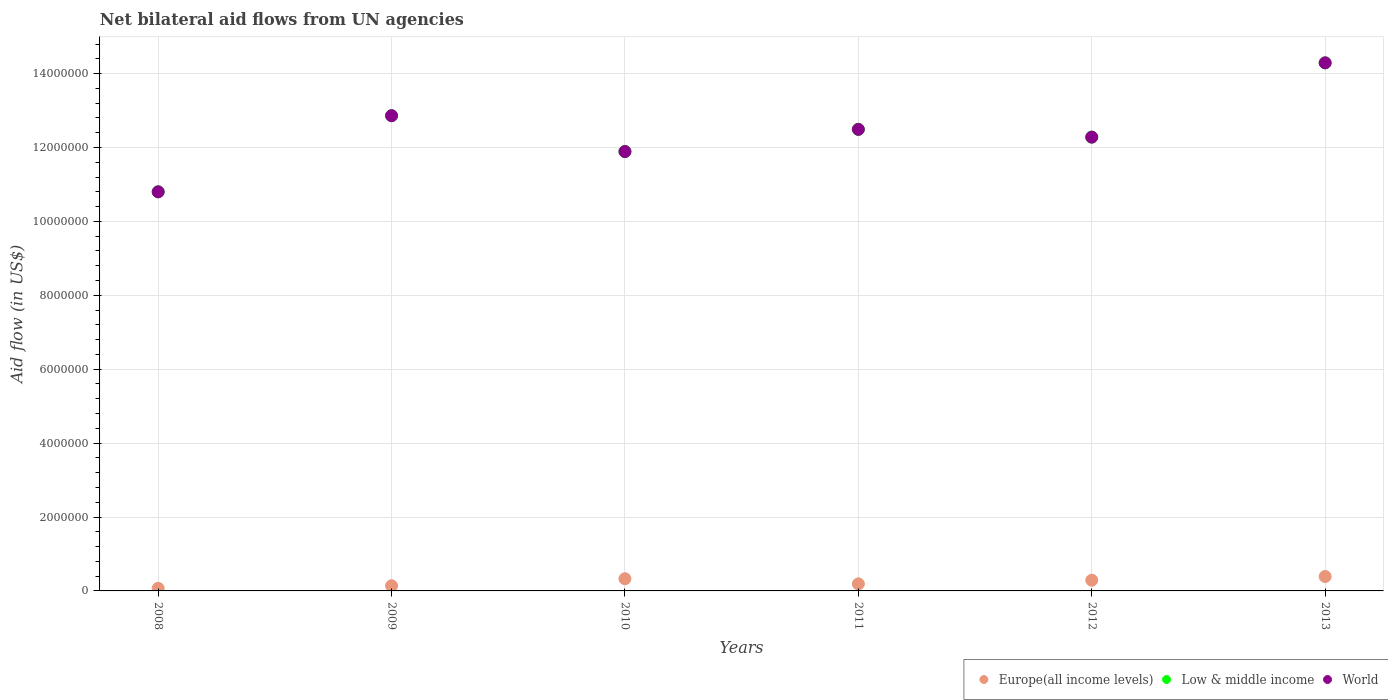What is the net bilateral aid flow in Europe(all income levels) in 2011?
Your answer should be compact. 1.90e+05. Across all years, what is the maximum net bilateral aid flow in Low & middle income?
Offer a very short reply. 1.43e+07. Across all years, what is the minimum net bilateral aid flow in Europe(all income levels)?
Provide a short and direct response. 7.00e+04. In which year was the net bilateral aid flow in Europe(all income levels) maximum?
Provide a succinct answer. 2013. In which year was the net bilateral aid flow in Europe(all income levels) minimum?
Provide a short and direct response. 2008. What is the total net bilateral aid flow in Europe(all income levels) in the graph?
Make the answer very short. 1.41e+06. What is the difference between the net bilateral aid flow in World in 2008 and that in 2013?
Offer a terse response. -3.49e+06. What is the difference between the net bilateral aid flow in Low & middle income in 2012 and the net bilateral aid flow in Europe(all income levels) in 2010?
Offer a very short reply. 1.20e+07. What is the average net bilateral aid flow in Low & middle income per year?
Your response must be concise. 1.24e+07. In the year 2010, what is the difference between the net bilateral aid flow in Low & middle income and net bilateral aid flow in World?
Your answer should be compact. 0. What is the ratio of the net bilateral aid flow in World in 2010 to that in 2011?
Ensure brevity in your answer.  0.95. Is the net bilateral aid flow in Low & middle income in 2011 less than that in 2012?
Offer a very short reply. No. Is the difference between the net bilateral aid flow in Low & middle income in 2010 and 2013 greater than the difference between the net bilateral aid flow in World in 2010 and 2013?
Keep it short and to the point. No. What is the difference between the highest and the second highest net bilateral aid flow in Europe(all income levels)?
Ensure brevity in your answer.  6.00e+04. What is the difference between the highest and the lowest net bilateral aid flow in World?
Offer a terse response. 3.49e+06. In how many years, is the net bilateral aid flow in Europe(all income levels) greater than the average net bilateral aid flow in Europe(all income levels) taken over all years?
Provide a succinct answer. 3. Is the sum of the net bilateral aid flow in World in 2008 and 2009 greater than the maximum net bilateral aid flow in Europe(all income levels) across all years?
Your answer should be compact. Yes. Is it the case that in every year, the sum of the net bilateral aid flow in Low & middle income and net bilateral aid flow in Europe(all income levels)  is greater than the net bilateral aid flow in World?
Provide a short and direct response. Yes. Does the net bilateral aid flow in World monotonically increase over the years?
Keep it short and to the point. No. How many dotlines are there?
Provide a short and direct response. 3. How many years are there in the graph?
Give a very brief answer. 6. What is the difference between two consecutive major ticks on the Y-axis?
Keep it short and to the point. 2.00e+06. Does the graph contain grids?
Offer a very short reply. Yes. How are the legend labels stacked?
Keep it short and to the point. Horizontal. What is the title of the graph?
Offer a very short reply. Net bilateral aid flows from UN agencies. Does "Euro area" appear as one of the legend labels in the graph?
Your answer should be compact. No. What is the label or title of the Y-axis?
Provide a succinct answer. Aid flow (in US$). What is the Aid flow (in US$) of Europe(all income levels) in 2008?
Give a very brief answer. 7.00e+04. What is the Aid flow (in US$) in Low & middle income in 2008?
Keep it short and to the point. 1.08e+07. What is the Aid flow (in US$) of World in 2008?
Your response must be concise. 1.08e+07. What is the Aid flow (in US$) in Europe(all income levels) in 2009?
Ensure brevity in your answer.  1.40e+05. What is the Aid flow (in US$) of Low & middle income in 2009?
Give a very brief answer. 1.29e+07. What is the Aid flow (in US$) of World in 2009?
Your answer should be very brief. 1.29e+07. What is the Aid flow (in US$) of Low & middle income in 2010?
Keep it short and to the point. 1.19e+07. What is the Aid flow (in US$) of World in 2010?
Give a very brief answer. 1.19e+07. What is the Aid flow (in US$) in Europe(all income levels) in 2011?
Offer a very short reply. 1.90e+05. What is the Aid flow (in US$) of Low & middle income in 2011?
Your answer should be compact. 1.25e+07. What is the Aid flow (in US$) of World in 2011?
Ensure brevity in your answer.  1.25e+07. What is the Aid flow (in US$) in Europe(all income levels) in 2012?
Your answer should be very brief. 2.90e+05. What is the Aid flow (in US$) of Low & middle income in 2012?
Offer a very short reply. 1.23e+07. What is the Aid flow (in US$) in World in 2012?
Offer a terse response. 1.23e+07. What is the Aid flow (in US$) in Europe(all income levels) in 2013?
Make the answer very short. 3.90e+05. What is the Aid flow (in US$) in Low & middle income in 2013?
Your response must be concise. 1.43e+07. What is the Aid flow (in US$) of World in 2013?
Offer a very short reply. 1.43e+07. Across all years, what is the maximum Aid flow (in US$) in Low & middle income?
Give a very brief answer. 1.43e+07. Across all years, what is the maximum Aid flow (in US$) in World?
Offer a terse response. 1.43e+07. Across all years, what is the minimum Aid flow (in US$) of Europe(all income levels)?
Your answer should be very brief. 7.00e+04. Across all years, what is the minimum Aid flow (in US$) in Low & middle income?
Your answer should be very brief. 1.08e+07. Across all years, what is the minimum Aid flow (in US$) in World?
Provide a succinct answer. 1.08e+07. What is the total Aid flow (in US$) in Europe(all income levels) in the graph?
Keep it short and to the point. 1.41e+06. What is the total Aid flow (in US$) of Low & middle income in the graph?
Give a very brief answer. 7.46e+07. What is the total Aid flow (in US$) of World in the graph?
Your response must be concise. 7.46e+07. What is the difference between the Aid flow (in US$) of Europe(all income levels) in 2008 and that in 2009?
Provide a short and direct response. -7.00e+04. What is the difference between the Aid flow (in US$) of Low & middle income in 2008 and that in 2009?
Offer a very short reply. -2.06e+06. What is the difference between the Aid flow (in US$) of World in 2008 and that in 2009?
Make the answer very short. -2.06e+06. What is the difference between the Aid flow (in US$) in Europe(all income levels) in 2008 and that in 2010?
Keep it short and to the point. -2.60e+05. What is the difference between the Aid flow (in US$) in Low & middle income in 2008 and that in 2010?
Your answer should be compact. -1.09e+06. What is the difference between the Aid flow (in US$) of World in 2008 and that in 2010?
Your answer should be compact. -1.09e+06. What is the difference between the Aid flow (in US$) in Low & middle income in 2008 and that in 2011?
Your answer should be compact. -1.69e+06. What is the difference between the Aid flow (in US$) of World in 2008 and that in 2011?
Your answer should be very brief. -1.69e+06. What is the difference between the Aid flow (in US$) of Europe(all income levels) in 2008 and that in 2012?
Your response must be concise. -2.20e+05. What is the difference between the Aid flow (in US$) in Low & middle income in 2008 and that in 2012?
Keep it short and to the point. -1.48e+06. What is the difference between the Aid flow (in US$) in World in 2008 and that in 2012?
Ensure brevity in your answer.  -1.48e+06. What is the difference between the Aid flow (in US$) of Europe(all income levels) in 2008 and that in 2013?
Keep it short and to the point. -3.20e+05. What is the difference between the Aid flow (in US$) of Low & middle income in 2008 and that in 2013?
Your answer should be very brief. -3.49e+06. What is the difference between the Aid flow (in US$) of World in 2008 and that in 2013?
Keep it short and to the point. -3.49e+06. What is the difference between the Aid flow (in US$) in Low & middle income in 2009 and that in 2010?
Your answer should be very brief. 9.70e+05. What is the difference between the Aid flow (in US$) of World in 2009 and that in 2010?
Offer a terse response. 9.70e+05. What is the difference between the Aid flow (in US$) of Europe(all income levels) in 2009 and that in 2011?
Provide a succinct answer. -5.00e+04. What is the difference between the Aid flow (in US$) of Low & middle income in 2009 and that in 2011?
Offer a terse response. 3.70e+05. What is the difference between the Aid flow (in US$) of Low & middle income in 2009 and that in 2012?
Keep it short and to the point. 5.80e+05. What is the difference between the Aid flow (in US$) in World in 2009 and that in 2012?
Your answer should be very brief. 5.80e+05. What is the difference between the Aid flow (in US$) in Europe(all income levels) in 2009 and that in 2013?
Your response must be concise. -2.50e+05. What is the difference between the Aid flow (in US$) of Low & middle income in 2009 and that in 2013?
Make the answer very short. -1.43e+06. What is the difference between the Aid flow (in US$) in World in 2009 and that in 2013?
Make the answer very short. -1.43e+06. What is the difference between the Aid flow (in US$) in Low & middle income in 2010 and that in 2011?
Give a very brief answer. -6.00e+05. What is the difference between the Aid flow (in US$) of World in 2010 and that in 2011?
Give a very brief answer. -6.00e+05. What is the difference between the Aid flow (in US$) in Europe(all income levels) in 2010 and that in 2012?
Give a very brief answer. 4.00e+04. What is the difference between the Aid flow (in US$) in Low & middle income in 2010 and that in 2012?
Offer a terse response. -3.90e+05. What is the difference between the Aid flow (in US$) of World in 2010 and that in 2012?
Give a very brief answer. -3.90e+05. What is the difference between the Aid flow (in US$) in Low & middle income in 2010 and that in 2013?
Your response must be concise. -2.40e+06. What is the difference between the Aid flow (in US$) of World in 2010 and that in 2013?
Offer a terse response. -2.40e+06. What is the difference between the Aid flow (in US$) in Low & middle income in 2011 and that in 2013?
Your response must be concise. -1.80e+06. What is the difference between the Aid flow (in US$) of World in 2011 and that in 2013?
Your answer should be compact. -1.80e+06. What is the difference between the Aid flow (in US$) in Low & middle income in 2012 and that in 2013?
Give a very brief answer. -2.01e+06. What is the difference between the Aid flow (in US$) of World in 2012 and that in 2013?
Offer a very short reply. -2.01e+06. What is the difference between the Aid flow (in US$) of Europe(all income levels) in 2008 and the Aid flow (in US$) of Low & middle income in 2009?
Provide a succinct answer. -1.28e+07. What is the difference between the Aid flow (in US$) of Europe(all income levels) in 2008 and the Aid flow (in US$) of World in 2009?
Provide a succinct answer. -1.28e+07. What is the difference between the Aid flow (in US$) of Low & middle income in 2008 and the Aid flow (in US$) of World in 2009?
Give a very brief answer. -2.06e+06. What is the difference between the Aid flow (in US$) of Europe(all income levels) in 2008 and the Aid flow (in US$) of Low & middle income in 2010?
Ensure brevity in your answer.  -1.18e+07. What is the difference between the Aid flow (in US$) in Europe(all income levels) in 2008 and the Aid flow (in US$) in World in 2010?
Provide a short and direct response. -1.18e+07. What is the difference between the Aid flow (in US$) in Low & middle income in 2008 and the Aid flow (in US$) in World in 2010?
Provide a short and direct response. -1.09e+06. What is the difference between the Aid flow (in US$) in Europe(all income levels) in 2008 and the Aid flow (in US$) in Low & middle income in 2011?
Your response must be concise. -1.24e+07. What is the difference between the Aid flow (in US$) in Europe(all income levels) in 2008 and the Aid flow (in US$) in World in 2011?
Offer a very short reply. -1.24e+07. What is the difference between the Aid flow (in US$) of Low & middle income in 2008 and the Aid flow (in US$) of World in 2011?
Provide a short and direct response. -1.69e+06. What is the difference between the Aid flow (in US$) of Europe(all income levels) in 2008 and the Aid flow (in US$) of Low & middle income in 2012?
Give a very brief answer. -1.22e+07. What is the difference between the Aid flow (in US$) in Europe(all income levels) in 2008 and the Aid flow (in US$) in World in 2012?
Your answer should be very brief. -1.22e+07. What is the difference between the Aid flow (in US$) in Low & middle income in 2008 and the Aid flow (in US$) in World in 2012?
Keep it short and to the point. -1.48e+06. What is the difference between the Aid flow (in US$) of Europe(all income levels) in 2008 and the Aid flow (in US$) of Low & middle income in 2013?
Make the answer very short. -1.42e+07. What is the difference between the Aid flow (in US$) in Europe(all income levels) in 2008 and the Aid flow (in US$) in World in 2013?
Offer a very short reply. -1.42e+07. What is the difference between the Aid flow (in US$) of Low & middle income in 2008 and the Aid flow (in US$) of World in 2013?
Keep it short and to the point. -3.49e+06. What is the difference between the Aid flow (in US$) in Europe(all income levels) in 2009 and the Aid flow (in US$) in Low & middle income in 2010?
Ensure brevity in your answer.  -1.18e+07. What is the difference between the Aid flow (in US$) in Europe(all income levels) in 2009 and the Aid flow (in US$) in World in 2010?
Provide a succinct answer. -1.18e+07. What is the difference between the Aid flow (in US$) of Low & middle income in 2009 and the Aid flow (in US$) of World in 2010?
Ensure brevity in your answer.  9.70e+05. What is the difference between the Aid flow (in US$) of Europe(all income levels) in 2009 and the Aid flow (in US$) of Low & middle income in 2011?
Your answer should be compact. -1.24e+07. What is the difference between the Aid flow (in US$) in Europe(all income levels) in 2009 and the Aid flow (in US$) in World in 2011?
Ensure brevity in your answer.  -1.24e+07. What is the difference between the Aid flow (in US$) in Low & middle income in 2009 and the Aid flow (in US$) in World in 2011?
Offer a terse response. 3.70e+05. What is the difference between the Aid flow (in US$) of Europe(all income levels) in 2009 and the Aid flow (in US$) of Low & middle income in 2012?
Keep it short and to the point. -1.21e+07. What is the difference between the Aid flow (in US$) in Europe(all income levels) in 2009 and the Aid flow (in US$) in World in 2012?
Provide a short and direct response. -1.21e+07. What is the difference between the Aid flow (in US$) of Low & middle income in 2009 and the Aid flow (in US$) of World in 2012?
Provide a short and direct response. 5.80e+05. What is the difference between the Aid flow (in US$) in Europe(all income levels) in 2009 and the Aid flow (in US$) in Low & middle income in 2013?
Make the answer very short. -1.42e+07. What is the difference between the Aid flow (in US$) in Europe(all income levels) in 2009 and the Aid flow (in US$) in World in 2013?
Offer a very short reply. -1.42e+07. What is the difference between the Aid flow (in US$) of Low & middle income in 2009 and the Aid flow (in US$) of World in 2013?
Your answer should be very brief. -1.43e+06. What is the difference between the Aid flow (in US$) of Europe(all income levels) in 2010 and the Aid flow (in US$) of Low & middle income in 2011?
Provide a succinct answer. -1.22e+07. What is the difference between the Aid flow (in US$) in Europe(all income levels) in 2010 and the Aid flow (in US$) in World in 2011?
Your response must be concise. -1.22e+07. What is the difference between the Aid flow (in US$) in Low & middle income in 2010 and the Aid flow (in US$) in World in 2011?
Give a very brief answer. -6.00e+05. What is the difference between the Aid flow (in US$) in Europe(all income levels) in 2010 and the Aid flow (in US$) in Low & middle income in 2012?
Offer a terse response. -1.20e+07. What is the difference between the Aid flow (in US$) in Europe(all income levels) in 2010 and the Aid flow (in US$) in World in 2012?
Your answer should be compact. -1.20e+07. What is the difference between the Aid flow (in US$) in Low & middle income in 2010 and the Aid flow (in US$) in World in 2012?
Offer a terse response. -3.90e+05. What is the difference between the Aid flow (in US$) in Europe(all income levels) in 2010 and the Aid flow (in US$) in Low & middle income in 2013?
Offer a very short reply. -1.40e+07. What is the difference between the Aid flow (in US$) of Europe(all income levels) in 2010 and the Aid flow (in US$) of World in 2013?
Offer a terse response. -1.40e+07. What is the difference between the Aid flow (in US$) in Low & middle income in 2010 and the Aid flow (in US$) in World in 2013?
Offer a terse response. -2.40e+06. What is the difference between the Aid flow (in US$) in Europe(all income levels) in 2011 and the Aid flow (in US$) in Low & middle income in 2012?
Offer a very short reply. -1.21e+07. What is the difference between the Aid flow (in US$) in Europe(all income levels) in 2011 and the Aid flow (in US$) in World in 2012?
Offer a very short reply. -1.21e+07. What is the difference between the Aid flow (in US$) of Low & middle income in 2011 and the Aid flow (in US$) of World in 2012?
Your answer should be compact. 2.10e+05. What is the difference between the Aid flow (in US$) in Europe(all income levels) in 2011 and the Aid flow (in US$) in Low & middle income in 2013?
Provide a short and direct response. -1.41e+07. What is the difference between the Aid flow (in US$) in Europe(all income levels) in 2011 and the Aid flow (in US$) in World in 2013?
Make the answer very short. -1.41e+07. What is the difference between the Aid flow (in US$) of Low & middle income in 2011 and the Aid flow (in US$) of World in 2013?
Provide a succinct answer. -1.80e+06. What is the difference between the Aid flow (in US$) of Europe(all income levels) in 2012 and the Aid flow (in US$) of Low & middle income in 2013?
Your response must be concise. -1.40e+07. What is the difference between the Aid flow (in US$) of Europe(all income levels) in 2012 and the Aid flow (in US$) of World in 2013?
Offer a terse response. -1.40e+07. What is the difference between the Aid flow (in US$) in Low & middle income in 2012 and the Aid flow (in US$) in World in 2013?
Give a very brief answer. -2.01e+06. What is the average Aid flow (in US$) of Europe(all income levels) per year?
Keep it short and to the point. 2.35e+05. What is the average Aid flow (in US$) in Low & middle income per year?
Offer a very short reply. 1.24e+07. What is the average Aid flow (in US$) of World per year?
Keep it short and to the point. 1.24e+07. In the year 2008, what is the difference between the Aid flow (in US$) of Europe(all income levels) and Aid flow (in US$) of Low & middle income?
Offer a very short reply. -1.07e+07. In the year 2008, what is the difference between the Aid flow (in US$) in Europe(all income levels) and Aid flow (in US$) in World?
Your response must be concise. -1.07e+07. In the year 2008, what is the difference between the Aid flow (in US$) of Low & middle income and Aid flow (in US$) of World?
Provide a succinct answer. 0. In the year 2009, what is the difference between the Aid flow (in US$) in Europe(all income levels) and Aid flow (in US$) in Low & middle income?
Provide a succinct answer. -1.27e+07. In the year 2009, what is the difference between the Aid flow (in US$) of Europe(all income levels) and Aid flow (in US$) of World?
Offer a terse response. -1.27e+07. In the year 2009, what is the difference between the Aid flow (in US$) of Low & middle income and Aid flow (in US$) of World?
Make the answer very short. 0. In the year 2010, what is the difference between the Aid flow (in US$) in Europe(all income levels) and Aid flow (in US$) in Low & middle income?
Make the answer very short. -1.16e+07. In the year 2010, what is the difference between the Aid flow (in US$) of Europe(all income levels) and Aid flow (in US$) of World?
Provide a short and direct response. -1.16e+07. In the year 2010, what is the difference between the Aid flow (in US$) of Low & middle income and Aid flow (in US$) of World?
Give a very brief answer. 0. In the year 2011, what is the difference between the Aid flow (in US$) in Europe(all income levels) and Aid flow (in US$) in Low & middle income?
Keep it short and to the point. -1.23e+07. In the year 2011, what is the difference between the Aid flow (in US$) of Europe(all income levels) and Aid flow (in US$) of World?
Your answer should be compact. -1.23e+07. In the year 2011, what is the difference between the Aid flow (in US$) of Low & middle income and Aid flow (in US$) of World?
Offer a very short reply. 0. In the year 2012, what is the difference between the Aid flow (in US$) of Europe(all income levels) and Aid flow (in US$) of Low & middle income?
Offer a terse response. -1.20e+07. In the year 2012, what is the difference between the Aid flow (in US$) of Europe(all income levels) and Aid flow (in US$) of World?
Ensure brevity in your answer.  -1.20e+07. In the year 2012, what is the difference between the Aid flow (in US$) in Low & middle income and Aid flow (in US$) in World?
Your answer should be compact. 0. In the year 2013, what is the difference between the Aid flow (in US$) in Europe(all income levels) and Aid flow (in US$) in Low & middle income?
Ensure brevity in your answer.  -1.39e+07. In the year 2013, what is the difference between the Aid flow (in US$) of Europe(all income levels) and Aid flow (in US$) of World?
Keep it short and to the point. -1.39e+07. What is the ratio of the Aid flow (in US$) of Low & middle income in 2008 to that in 2009?
Provide a short and direct response. 0.84. What is the ratio of the Aid flow (in US$) of World in 2008 to that in 2009?
Your response must be concise. 0.84. What is the ratio of the Aid flow (in US$) in Europe(all income levels) in 2008 to that in 2010?
Your response must be concise. 0.21. What is the ratio of the Aid flow (in US$) in Low & middle income in 2008 to that in 2010?
Make the answer very short. 0.91. What is the ratio of the Aid flow (in US$) in World in 2008 to that in 2010?
Provide a succinct answer. 0.91. What is the ratio of the Aid flow (in US$) of Europe(all income levels) in 2008 to that in 2011?
Give a very brief answer. 0.37. What is the ratio of the Aid flow (in US$) of Low & middle income in 2008 to that in 2011?
Your answer should be very brief. 0.86. What is the ratio of the Aid flow (in US$) in World in 2008 to that in 2011?
Make the answer very short. 0.86. What is the ratio of the Aid flow (in US$) of Europe(all income levels) in 2008 to that in 2012?
Give a very brief answer. 0.24. What is the ratio of the Aid flow (in US$) in Low & middle income in 2008 to that in 2012?
Make the answer very short. 0.88. What is the ratio of the Aid flow (in US$) in World in 2008 to that in 2012?
Offer a terse response. 0.88. What is the ratio of the Aid flow (in US$) of Europe(all income levels) in 2008 to that in 2013?
Your answer should be very brief. 0.18. What is the ratio of the Aid flow (in US$) of Low & middle income in 2008 to that in 2013?
Your answer should be compact. 0.76. What is the ratio of the Aid flow (in US$) of World in 2008 to that in 2013?
Keep it short and to the point. 0.76. What is the ratio of the Aid flow (in US$) of Europe(all income levels) in 2009 to that in 2010?
Provide a succinct answer. 0.42. What is the ratio of the Aid flow (in US$) of Low & middle income in 2009 to that in 2010?
Offer a terse response. 1.08. What is the ratio of the Aid flow (in US$) in World in 2009 to that in 2010?
Provide a succinct answer. 1.08. What is the ratio of the Aid flow (in US$) of Europe(all income levels) in 2009 to that in 2011?
Provide a succinct answer. 0.74. What is the ratio of the Aid flow (in US$) in Low & middle income in 2009 to that in 2011?
Provide a succinct answer. 1.03. What is the ratio of the Aid flow (in US$) in World in 2009 to that in 2011?
Provide a succinct answer. 1.03. What is the ratio of the Aid flow (in US$) in Europe(all income levels) in 2009 to that in 2012?
Provide a short and direct response. 0.48. What is the ratio of the Aid flow (in US$) of Low & middle income in 2009 to that in 2012?
Keep it short and to the point. 1.05. What is the ratio of the Aid flow (in US$) of World in 2009 to that in 2012?
Make the answer very short. 1.05. What is the ratio of the Aid flow (in US$) in Europe(all income levels) in 2009 to that in 2013?
Keep it short and to the point. 0.36. What is the ratio of the Aid flow (in US$) of Low & middle income in 2009 to that in 2013?
Make the answer very short. 0.9. What is the ratio of the Aid flow (in US$) of World in 2009 to that in 2013?
Make the answer very short. 0.9. What is the ratio of the Aid flow (in US$) in Europe(all income levels) in 2010 to that in 2011?
Ensure brevity in your answer.  1.74. What is the ratio of the Aid flow (in US$) in Low & middle income in 2010 to that in 2011?
Keep it short and to the point. 0.95. What is the ratio of the Aid flow (in US$) in World in 2010 to that in 2011?
Provide a short and direct response. 0.95. What is the ratio of the Aid flow (in US$) in Europe(all income levels) in 2010 to that in 2012?
Offer a terse response. 1.14. What is the ratio of the Aid flow (in US$) in Low & middle income in 2010 to that in 2012?
Provide a short and direct response. 0.97. What is the ratio of the Aid flow (in US$) in World in 2010 to that in 2012?
Offer a terse response. 0.97. What is the ratio of the Aid flow (in US$) in Europe(all income levels) in 2010 to that in 2013?
Your answer should be very brief. 0.85. What is the ratio of the Aid flow (in US$) of Low & middle income in 2010 to that in 2013?
Your answer should be very brief. 0.83. What is the ratio of the Aid flow (in US$) in World in 2010 to that in 2013?
Your answer should be compact. 0.83. What is the ratio of the Aid flow (in US$) of Europe(all income levels) in 2011 to that in 2012?
Offer a very short reply. 0.66. What is the ratio of the Aid flow (in US$) of Low & middle income in 2011 to that in 2012?
Your response must be concise. 1.02. What is the ratio of the Aid flow (in US$) of World in 2011 to that in 2012?
Keep it short and to the point. 1.02. What is the ratio of the Aid flow (in US$) of Europe(all income levels) in 2011 to that in 2013?
Make the answer very short. 0.49. What is the ratio of the Aid flow (in US$) of Low & middle income in 2011 to that in 2013?
Your response must be concise. 0.87. What is the ratio of the Aid flow (in US$) in World in 2011 to that in 2013?
Provide a succinct answer. 0.87. What is the ratio of the Aid flow (in US$) in Europe(all income levels) in 2012 to that in 2013?
Offer a very short reply. 0.74. What is the ratio of the Aid flow (in US$) in Low & middle income in 2012 to that in 2013?
Provide a short and direct response. 0.86. What is the ratio of the Aid flow (in US$) of World in 2012 to that in 2013?
Your answer should be compact. 0.86. What is the difference between the highest and the second highest Aid flow (in US$) in Low & middle income?
Your answer should be compact. 1.43e+06. What is the difference between the highest and the second highest Aid flow (in US$) in World?
Your answer should be very brief. 1.43e+06. What is the difference between the highest and the lowest Aid flow (in US$) in Low & middle income?
Provide a short and direct response. 3.49e+06. What is the difference between the highest and the lowest Aid flow (in US$) of World?
Offer a terse response. 3.49e+06. 